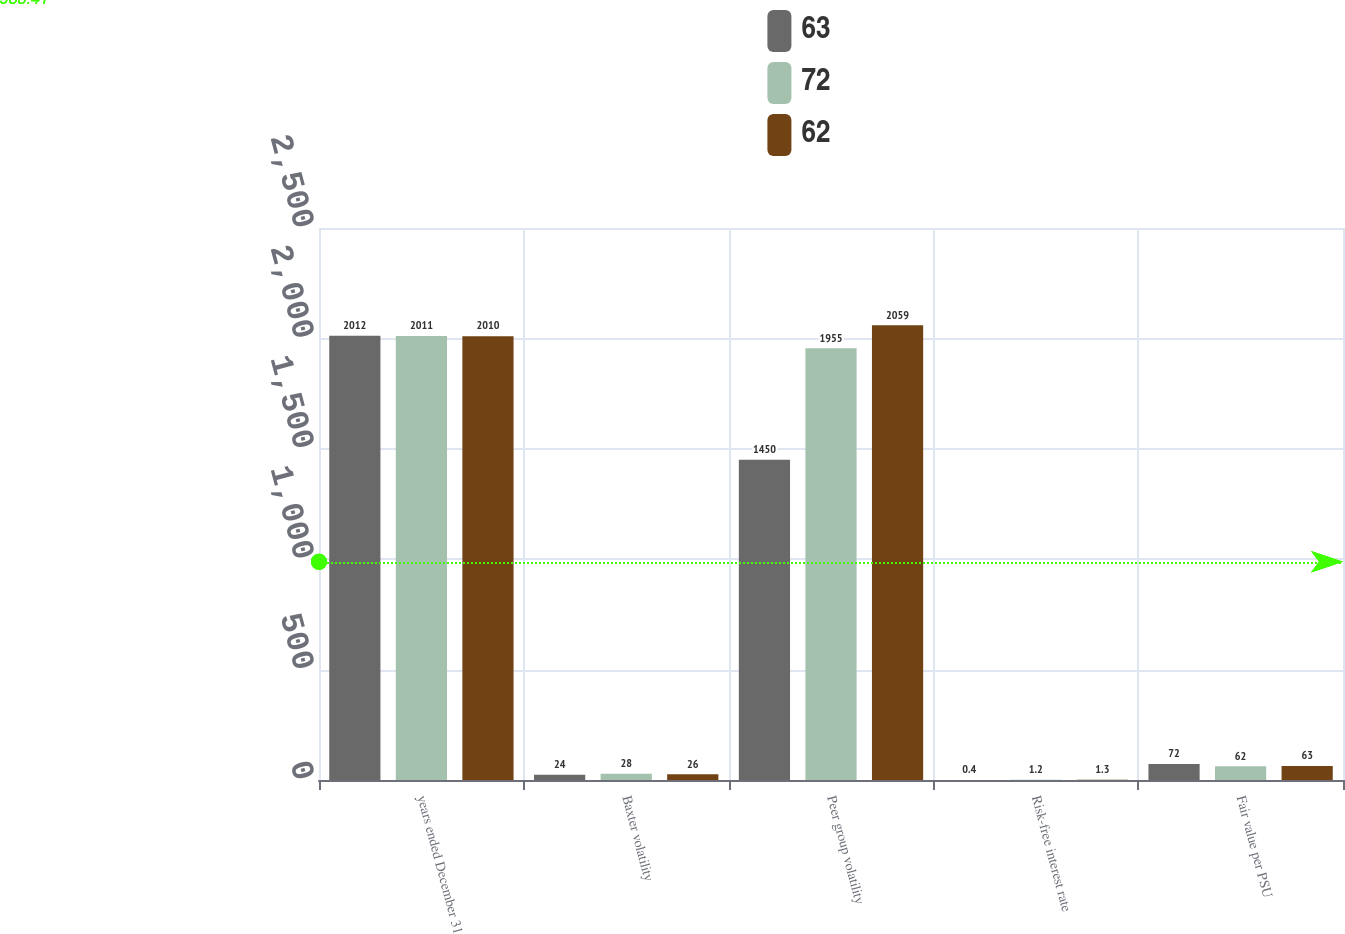<chart> <loc_0><loc_0><loc_500><loc_500><stacked_bar_chart><ecel><fcel>years ended December 31<fcel>Baxter volatility<fcel>Peer group volatility<fcel>Risk-free interest rate<fcel>Fair value per PSU<nl><fcel>63<fcel>2012<fcel>24<fcel>1450<fcel>0.4<fcel>72<nl><fcel>72<fcel>2011<fcel>28<fcel>1955<fcel>1.2<fcel>62<nl><fcel>62<fcel>2010<fcel>26<fcel>2059<fcel>1.3<fcel>63<nl></chart> 